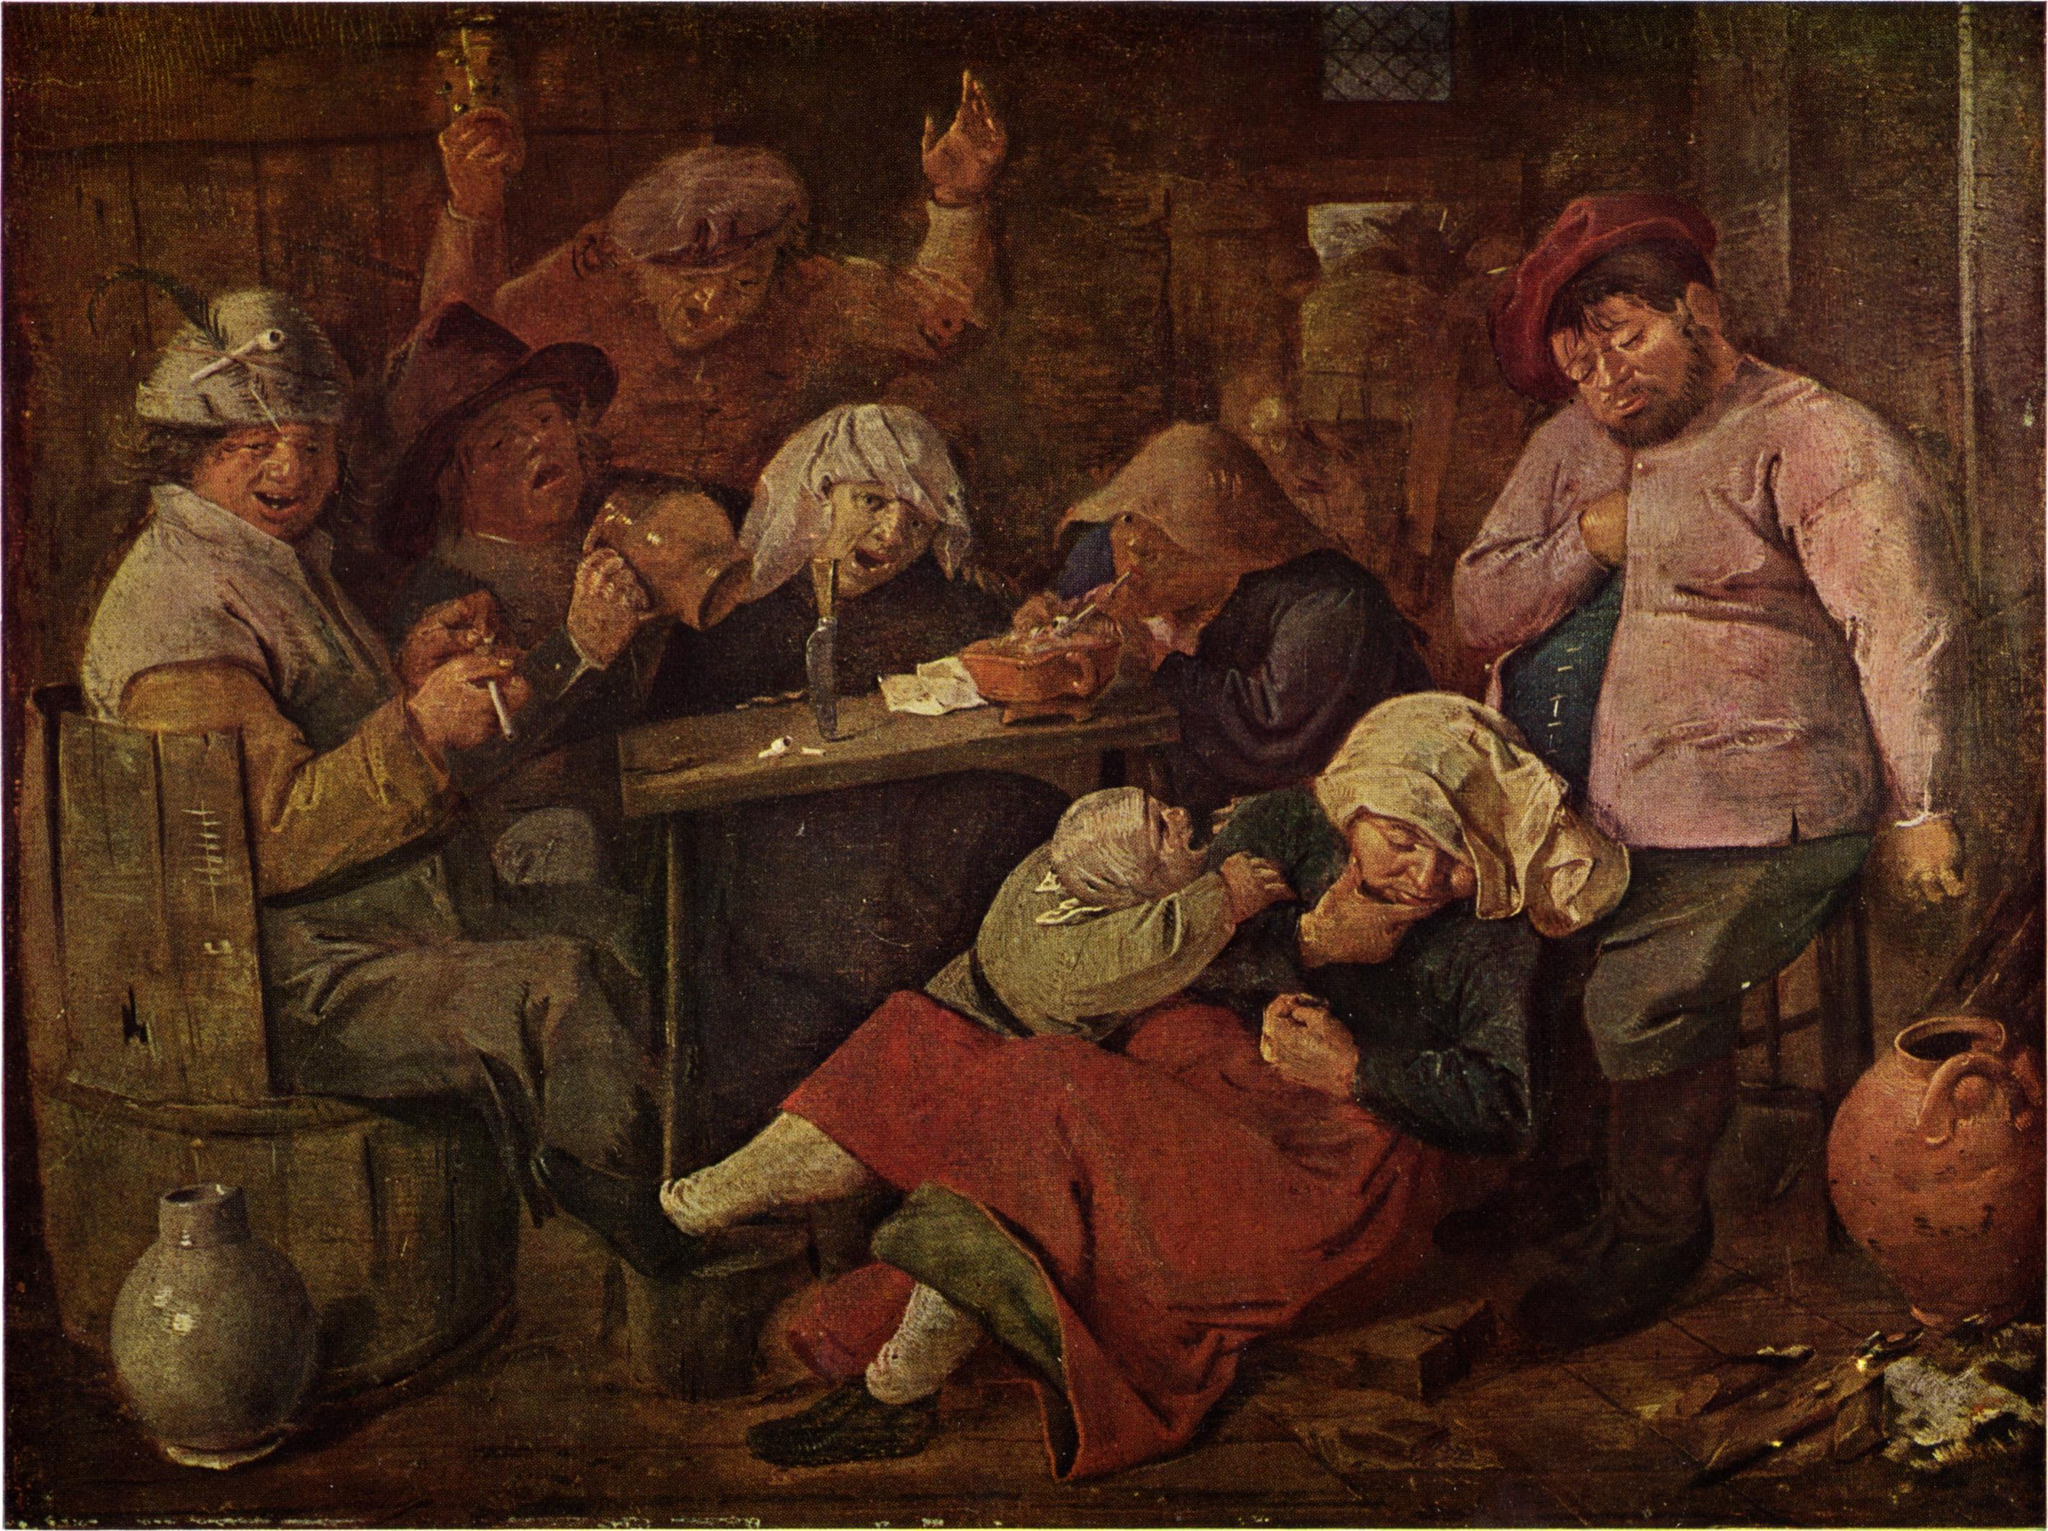Imagine if this scene was taking place in a modern-day setting. How might it look? In a modern-day setting, this scene might be set in a cozy, dimly lit bar rather than a rustic tavern. Instead of 17th-century attire, the people would be wearing contemporary casual clothing such as jeans, t-shirts, and light jackets. The table might be scattered with modern items like smartphones, beer bottles, and perhaps even a pizza box. The lighting could come from overhead bulbs rather than a candle, casting a warm, inviting glow over the group. Instead of playing cards, some might be focused on their phones or engaged in animated conversations. The essence of camaraderie and leisure would remain unchanged, but the details would reflect the lifestyle of the 21st century. If one could interact with the people in the painting, what questions might they ask? Interacting with the people in the painting, one might ask: 'What stories do you have to share from your daily life?' or 'What games are you playing, and how do you enjoy your time here?' Another interesting question could be, 'How has your community and way of life changed over time?' These questions would open a window into understanding their world, their relationships, and their cultural practices, providing deeper insight into life during the Dutch Golden Age.  Create a story where the people in this painting find a hidden treasure. In a small Dutch tavern teeming with laughter and camaraderie, a sudden hush falls over the patrons as an old, weathered map is unfurled across the table. The map, discovered by a curious young woman while cleaning the attic of her ancestral home, hints at a hidden treasure buried centuries ago near the town. The group, intrigued by the prospect, decides to embark on this unexpected adventure. United by a shared excitement, they gather supplies and set out at dawn, their journey filled with challenges, mysterious clues, and burgeoning friendships. Their adventure leads them through picturesque meadows, dense forests, and ancient ruins, each step drawing them closer to the legendary treasure. When they eventually unearth an ornate chest brimming with gold coins, precious jewels, and historical artifacts, the find not only rewards them materially but also binds their community closer, forging stories that would be told and retold for generations. The experience enriches their lives beyond measure, forever changing their perception of history and the bonds of companionship. 